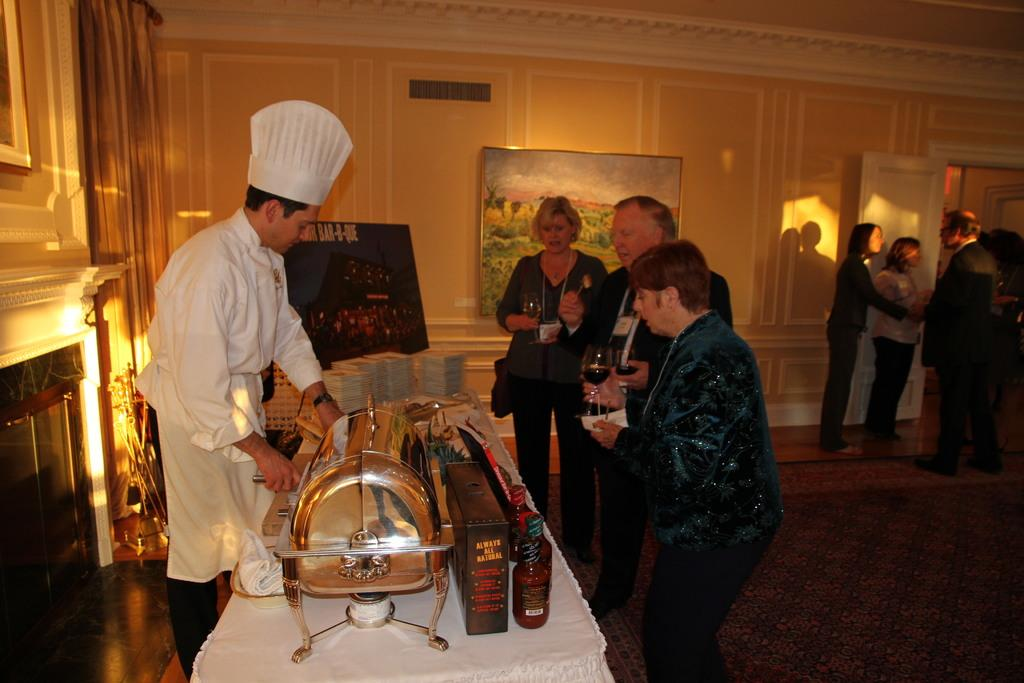Who or what is present in the image? There are people in the image. What can be seen on a surface in the image? There are objects on a table in the image. What is hanging on the wall in the background of the image? There is a photo frame on the wall in the background of the image. Can you hear the chicken cry in the image? There is no chicken present in the image, so it cannot be heard crying. 